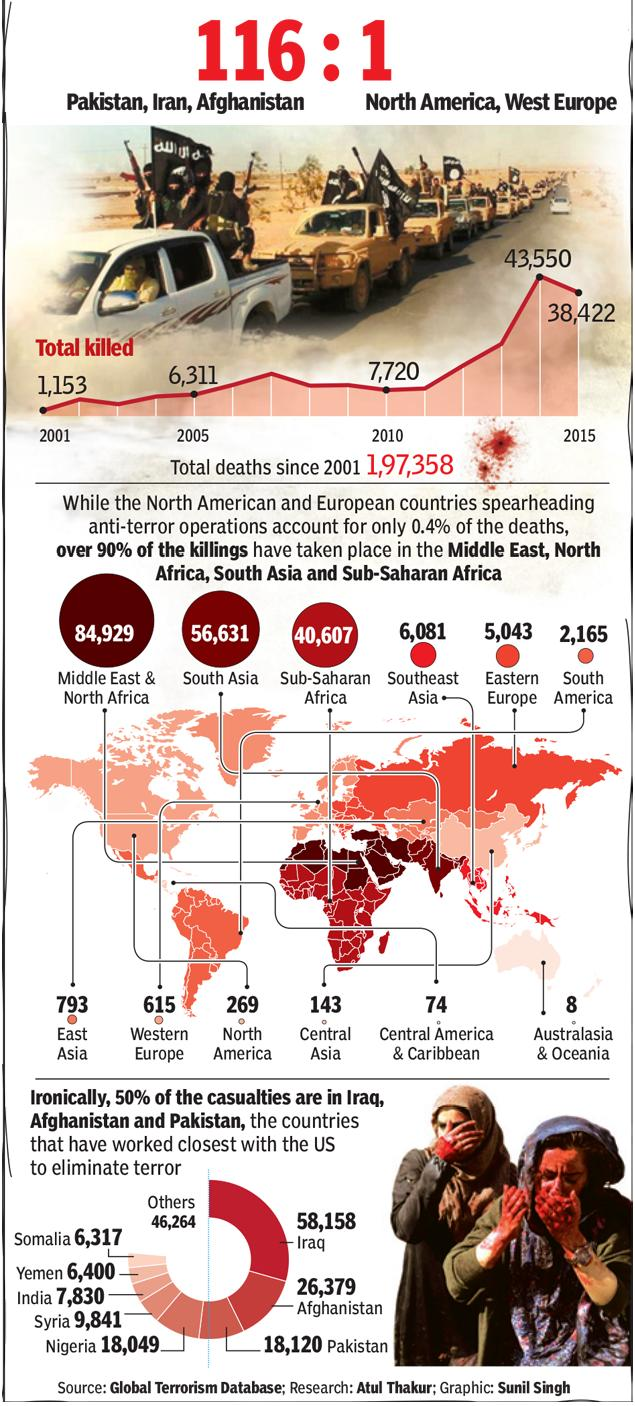Give some essential details in this illustration. In South Asia, there were a total of 56,631 deaths reported. According to the given data, South Asia had a higher number of deaths than both East Asia and South America. In 2007, there were more deaths than in 2005. There were 58,158 casualties in Iraq. Australasia and Oceania have the least number of deaths out of all the regions. 